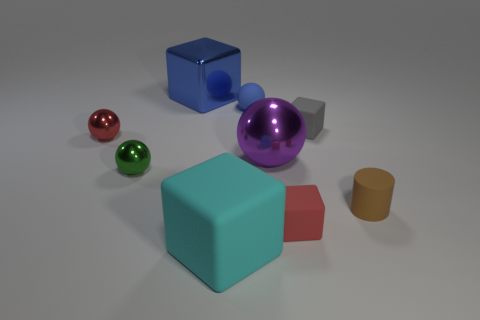There is a metal object that is both right of the small green metal object and on the left side of the big matte block; what is its size?
Your answer should be very brief. Large. There is a small object to the left of the green metal sphere; what is it made of?
Make the answer very short. Metal. There is a big rubber thing; is its color the same as the small sphere that is in front of the red metallic sphere?
Offer a very short reply. No. How many things are tiny spheres behind the gray rubber object or large objects that are behind the red rubber cube?
Your answer should be compact. 3. What is the color of the cube that is on the right side of the purple metallic object and behind the tiny cylinder?
Offer a very short reply. Gray. Are there more purple balls than spheres?
Keep it short and to the point. No. There is a large metallic object that is behind the big purple metal object; is its shape the same as the blue rubber thing?
Ensure brevity in your answer.  No. What number of rubber things are either green objects or big gray spheres?
Ensure brevity in your answer.  0. Is there a large cyan block made of the same material as the gray cube?
Provide a succinct answer. Yes. What material is the green sphere?
Offer a terse response. Metal. 